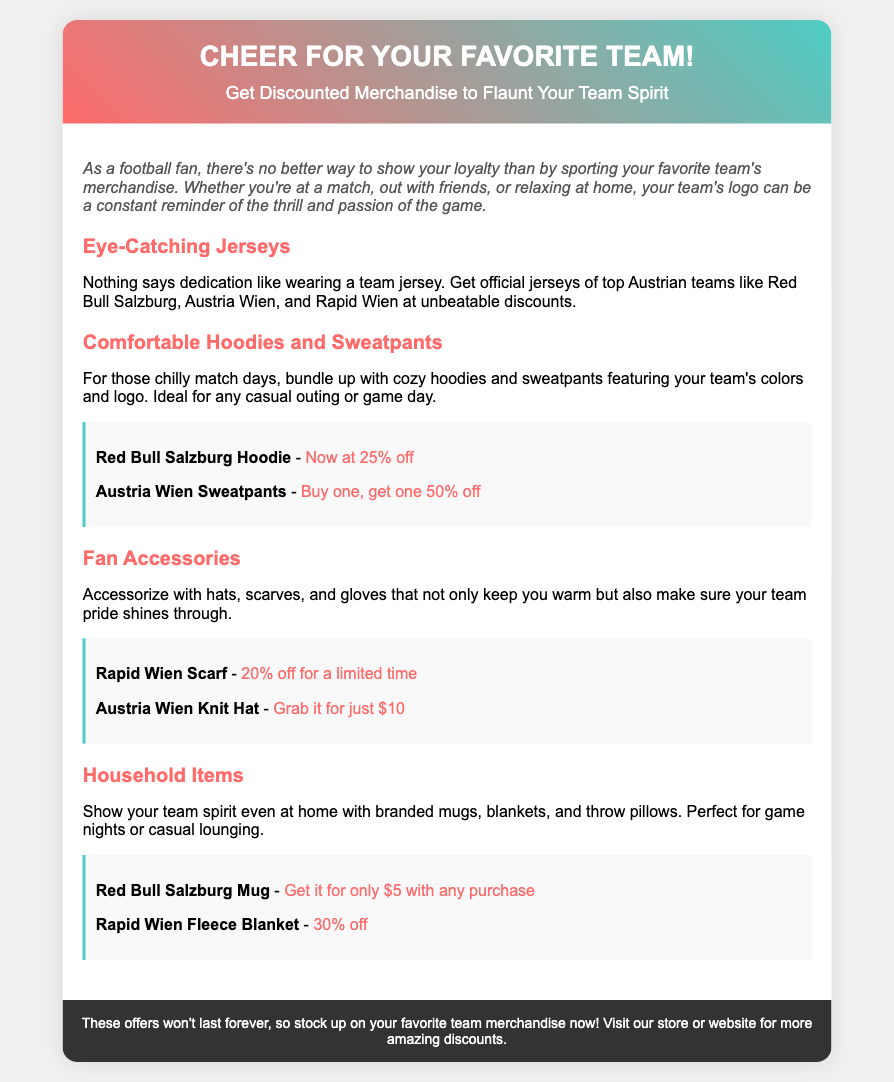What is the title of the voucher? The title of the voucher is prominently displayed at the top of the document.
Answer: Cheer for Your Favorite Team! Which team’s hoodie is offered at 25% off? The discount information for the hoodie is clearly stated in the corresponding section.
Answer: Red Bull Salzburg Hoodie What is the discount on Rapid Wien scarves? The document specifies the promotional offers for fan accessories, including scarves.
Answer: 20% off for a limited time What kitchen item can you get for $5 with any purchase? The household items section lists several merchandise, specifying the promotional price.
Answer: Red Bull Salzburg Mug What type of clothing is associated with “buy one, get one 50% off”? The information outlines discounts on clothing items, highlighting specific promotions.
Answer: Austria Wien Sweatpants How much is the Austria Wien Knit Hat? The price of the knit hat is mentioned in the accessories section of the document.
Answer: Just $10 